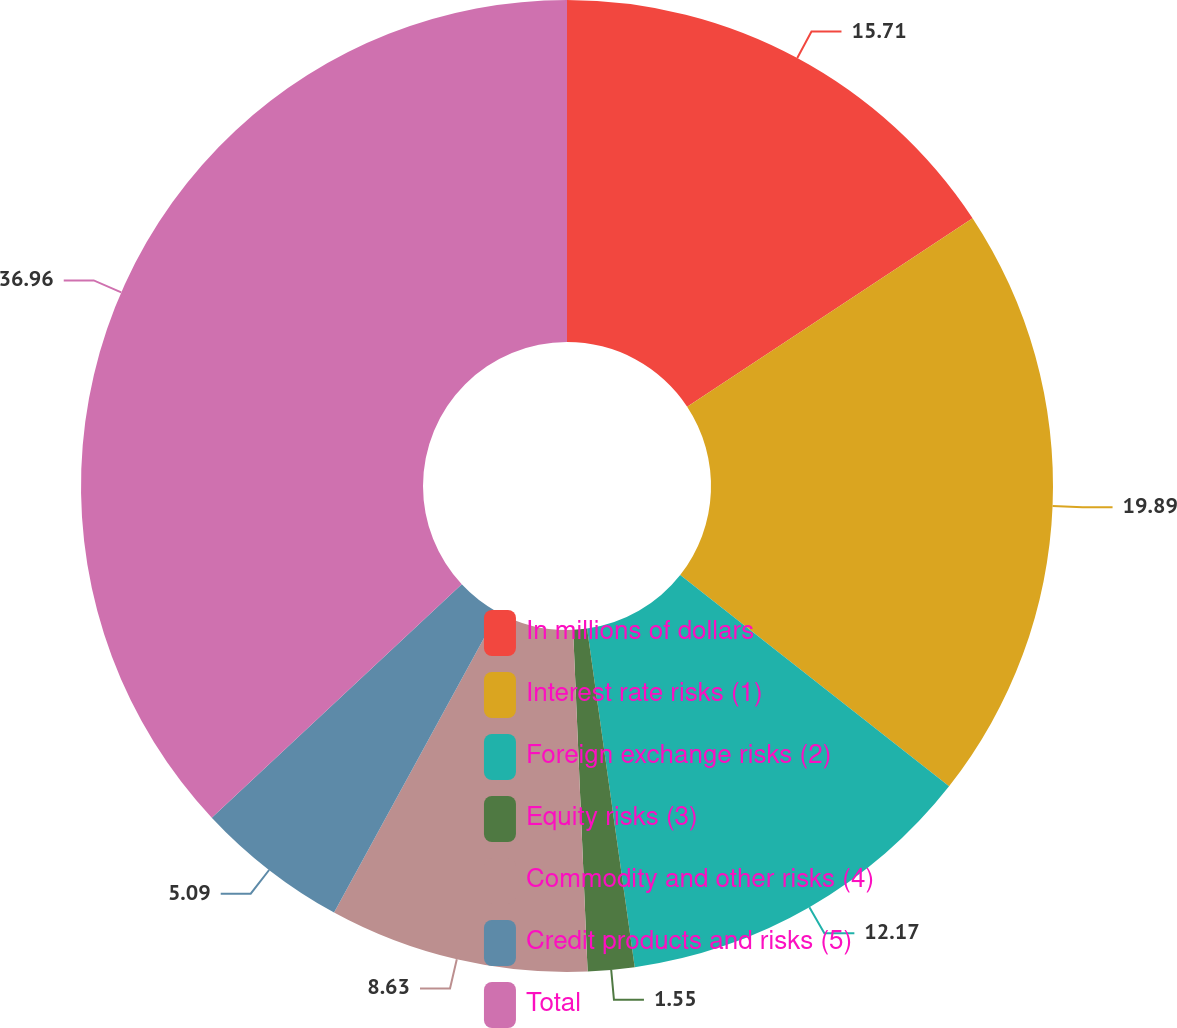Convert chart. <chart><loc_0><loc_0><loc_500><loc_500><pie_chart><fcel>In millions of dollars<fcel>Interest rate risks (1)<fcel>Foreign exchange risks (2)<fcel>Equity risks (3)<fcel>Commodity and other risks (4)<fcel>Credit products and risks (5)<fcel>Total<nl><fcel>15.71%<fcel>19.89%<fcel>12.17%<fcel>1.55%<fcel>8.63%<fcel>5.09%<fcel>36.95%<nl></chart> 